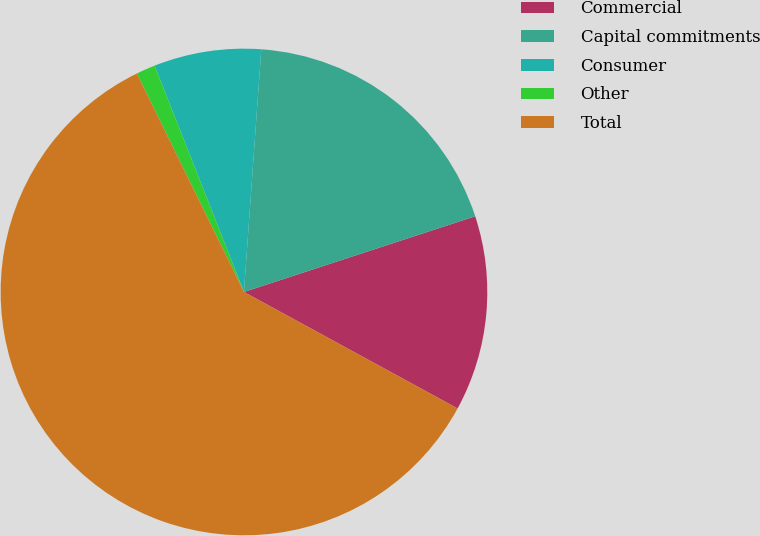<chart> <loc_0><loc_0><loc_500><loc_500><pie_chart><fcel>Commercial<fcel>Capital commitments<fcel>Consumer<fcel>Other<fcel>Total<nl><fcel>12.98%<fcel>18.83%<fcel>7.12%<fcel>1.27%<fcel>59.8%<nl></chart> 